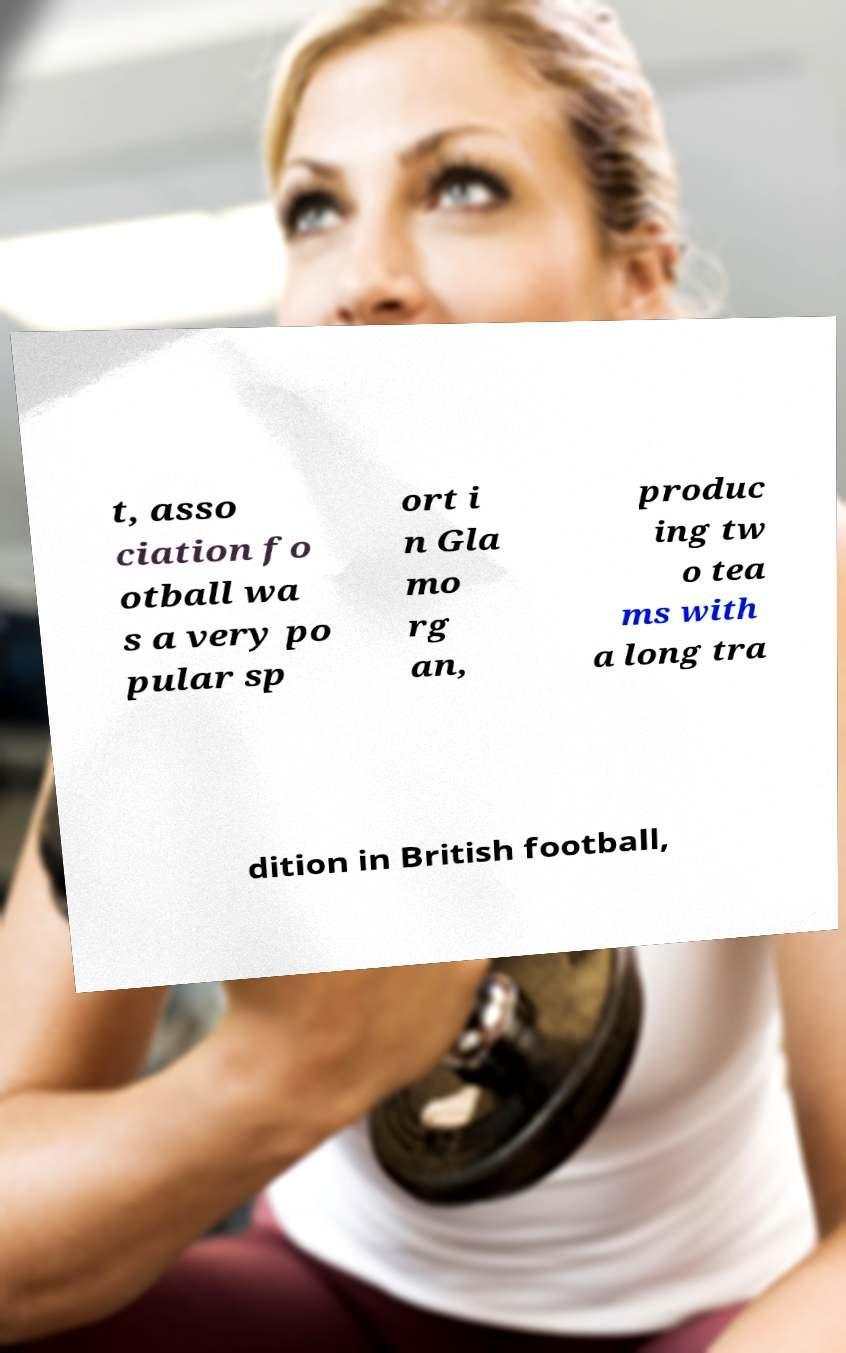There's text embedded in this image that I need extracted. Can you transcribe it verbatim? t, asso ciation fo otball wa s a very po pular sp ort i n Gla mo rg an, produc ing tw o tea ms with a long tra dition in British football, 